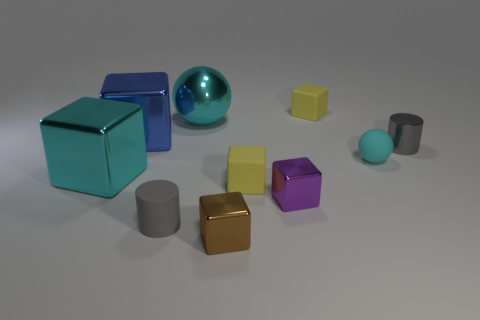Subtract all large cyan metallic blocks. How many blocks are left? 5 Subtract all cyan cubes. How many cubes are left? 5 Subtract 2 spheres. How many spheres are left? 0 Subtract all yellow balls. Subtract all gray blocks. How many balls are left? 2 Subtract all red blocks. How many purple balls are left? 0 Subtract all red shiny spheres. Subtract all brown shiny cubes. How many objects are left? 9 Add 4 small rubber blocks. How many small rubber blocks are left? 6 Add 8 big brown things. How many big brown things exist? 8 Subtract 1 blue blocks. How many objects are left? 9 Subtract all cylinders. How many objects are left? 8 